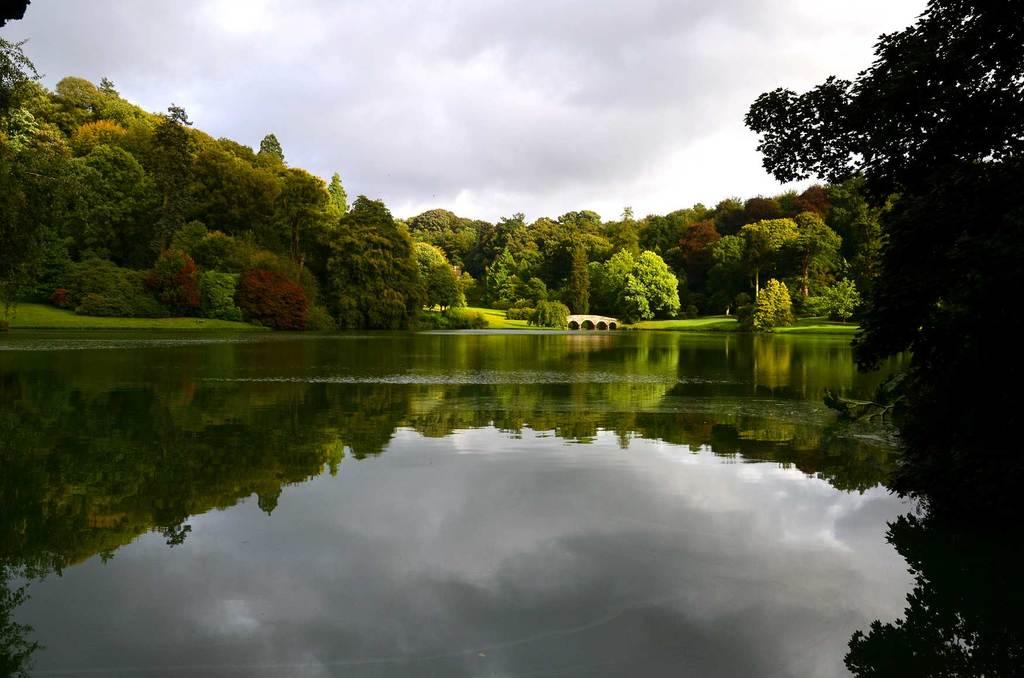What type of natural elements can be seen in the image? There are trees and water visible in the image. What man-made structure is present in the image? There is a bridge in the image. What is the condition of the sky in the image? The sky is cloudy in the image. How much profit can be made from the tent in the image? There is no tent present in the image, so it is not possible to determine any potential profit. 